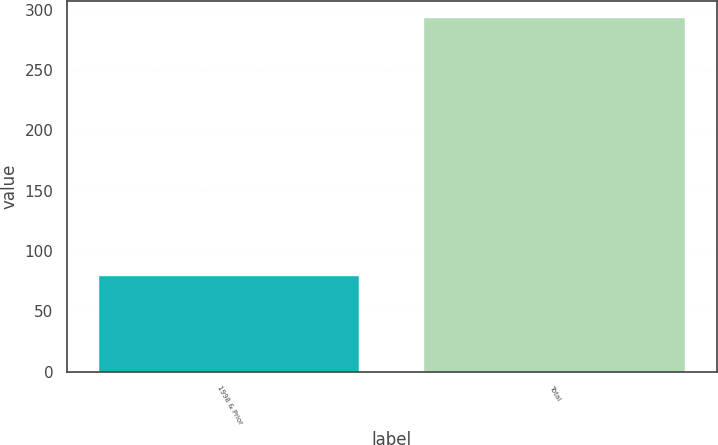<chart> <loc_0><loc_0><loc_500><loc_500><bar_chart><fcel>1998 & Prior<fcel>Total<nl><fcel>79<fcel>293<nl></chart> 